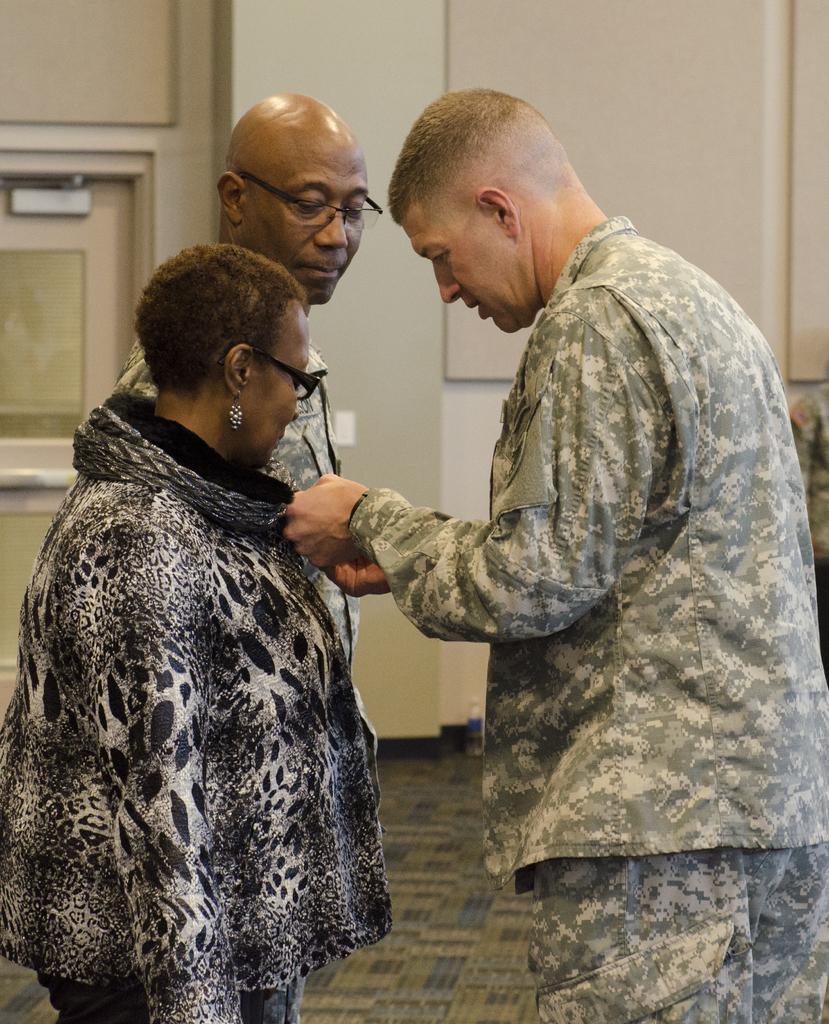Could you give a brief overview of what you see in this image? In this image I can see three persons standing. Two of them are wearing spectacles. 